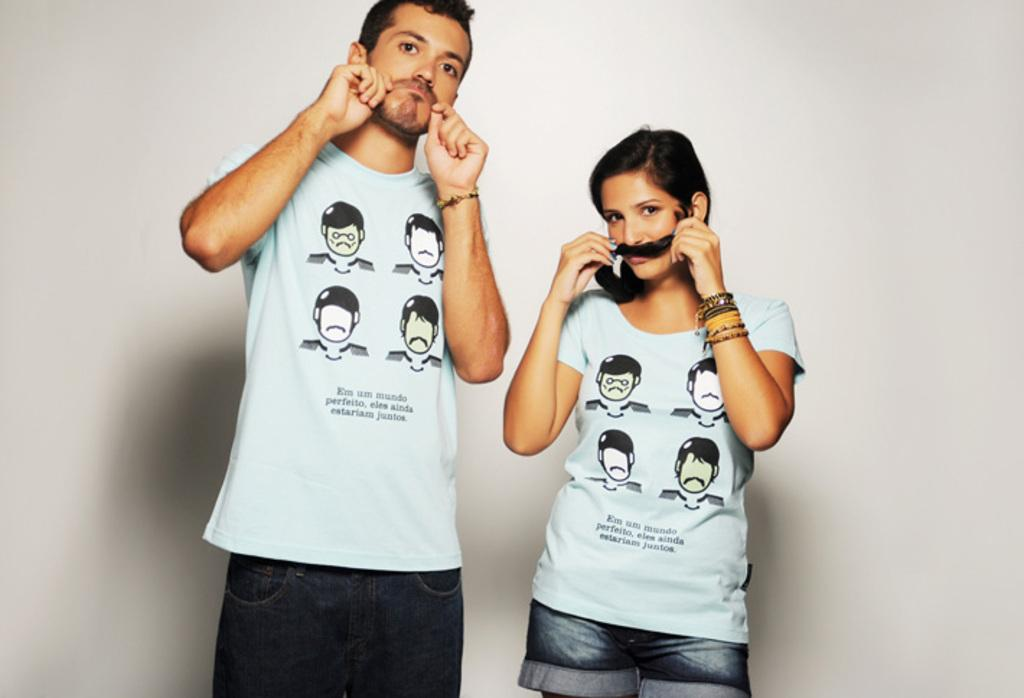How many individuals are present in the image? There are two people in the image. What type of brake system can be seen on the teeth of the individuals in the image? There are no brake systems or teeth visible in the image, as it features two people without any reference to their dental health or any mechanical devices. 